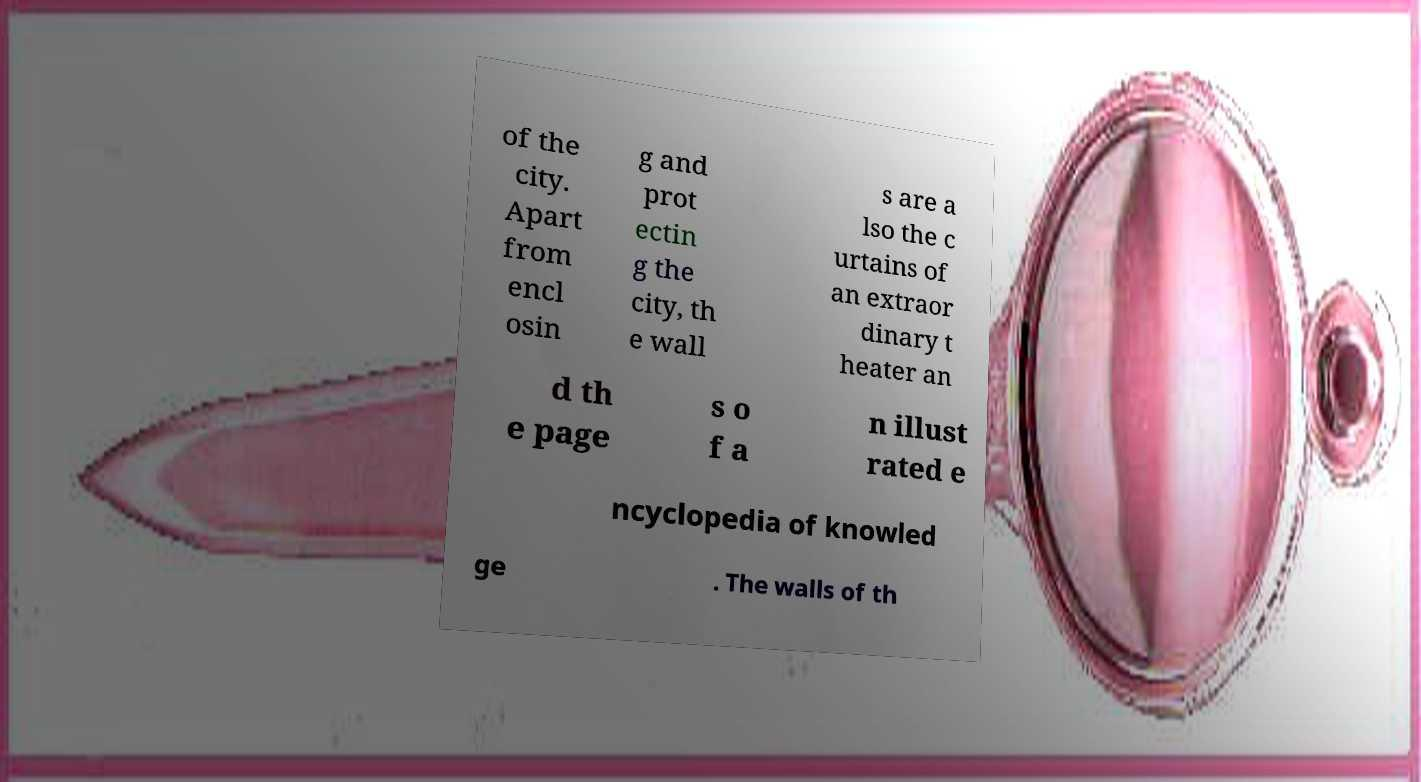Can you accurately transcribe the text from the provided image for me? of the city. Apart from encl osin g and prot ectin g the city, th e wall s are a lso the c urtains of an extraor dinary t heater an d th e page s o f a n illust rated e ncyclopedia of knowled ge . The walls of th 